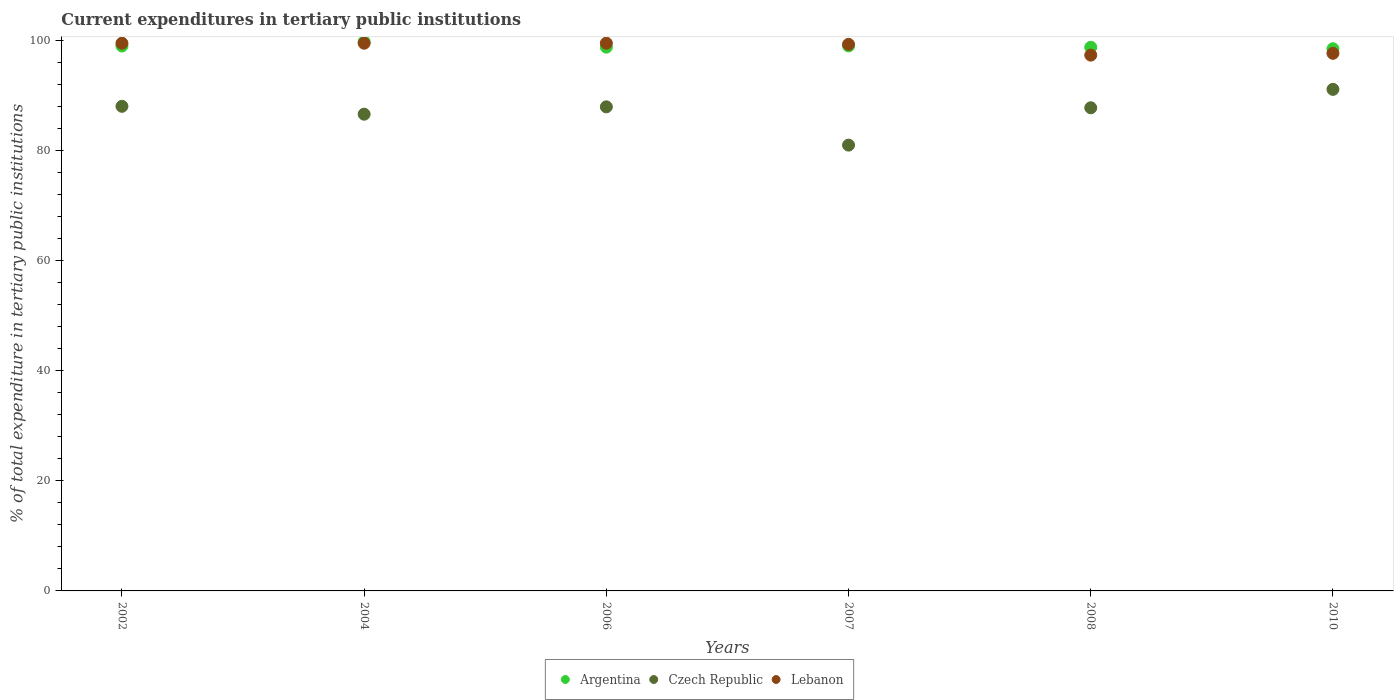How many different coloured dotlines are there?
Keep it short and to the point. 3. Is the number of dotlines equal to the number of legend labels?
Your answer should be compact. Yes. What is the current expenditures in tertiary public institutions in Czech Republic in 2002?
Your answer should be very brief. 88.1. Across all years, what is the maximum current expenditures in tertiary public institutions in Czech Republic?
Keep it short and to the point. 91.18. Across all years, what is the minimum current expenditures in tertiary public institutions in Lebanon?
Ensure brevity in your answer.  97.41. In which year was the current expenditures in tertiary public institutions in Argentina maximum?
Keep it short and to the point. 2004. In which year was the current expenditures in tertiary public institutions in Czech Republic minimum?
Give a very brief answer. 2007. What is the total current expenditures in tertiary public institutions in Czech Republic in the graph?
Your answer should be compact. 522.85. What is the difference between the current expenditures in tertiary public institutions in Argentina in 2007 and that in 2010?
Keep it short and to the point. 0.52. What is the difference between the current expenditures in tertiary public institutions in Lebanon in 2004 and the current expenditures in tertiary public institutions in Czech Republic in 2008?
Your answer should be very brief. 11.74. What is the average current expenditures in tertiary public institutions in Czech Republic per year?
Provide a short and direct response. 87.14. In the year 2006, what is the difference between the current expenditures in tertiary public institutions in Lebanon and current expenditures in tertiary public institutions in Argentina?
Provide a succinct answer. 0.71. In how many years, is the current expenditures in tertiary public institutions in Argentina greater than 36 %?
Provide a succinct answer. 6. What is the ratio of the current expenditures in tertiary public institutions in Czech Republic in 2002 to that in 2007?
Give a very brief answer. 1.09. What is the difference between the highest and the second highest current expenditures in tertiary public institutions in Lebanon?
Provide a succinct answer. 0. What is the difference between the highest and the lowest current expenditures in tertiary public institutions in Lebanon?
Provide a short and direct response. 2.17. Is the sum of the current expenditures in tertiary public institutions in Argentina in 2002 and 2006 greater than the maximum current expenditures in tertiary public institutions in Czech Republic across all years?
Keep it short and to the point. Yes. Does the current expenditures in tertiary public institutions in Argentina monotonically increase over the years?
Provide a succinct answer. No. How many dotlines are there?
Provide a succinct answer. 3. What is the difference between two consecutive major ticks on the Y-axis?
Keep it short and to the point. 20. Are the values on the major ticks of Y-axis written in scientific E-notation?
Your answer should be compact. No. Does the graph contain any zero values?
Your answer should be very brief. No. Where does the legend appear in the graph?
Your answer should be compact. Bottom center. What is the title of the graph?
Offer a very short reply. Current expenditures in tertiary public institutions. What is the label or title of the X-axis?
Provide a succinct answer. Years. What is the label or title of the Y-axis?
Give a very brief answer. % of total expenditure in tertiary public institutions. What is the % of total expenditure in tertiary public institutions of Argentina in 2002?
Your response must be concise. 99.07. What is the % of total expenditure in tertiary public institutions of Czech Republic in 2002?
Provide a short and direct response. 88.1. What is the % of total expenditure in tertiary public institutions of Lebanon in 2002?
Your response must be concise. 99.57. What is the % of total expenditure in tertiary public institutions of Argentina in 2004?
Your answer should be very brief. 99.84. What is the % of total expenditure in tertiary public institutions of Czech Republic in 2004?
Give a very brief answer. 86.67. What is the % of total expenditure in tertiary public institutions of Lebanon in 2004?
Your answer should be compact. 99.57. What is the % of total expenditure in tertiary public institutions in Argentina in 2006?
Give a very brief answer. 98.86. What is the % of total expenditure in tertiary public institutions of Czech Republic in 2006?
Your response must be concise. 88.01. What is the % of total expenditure in tertiary public institutions of Lebanon in 2006?
Your answer should be very brief. 99.58. What is the % of total expenditure in tertiary public institutions of Argentina in 2007?
Give a very brief answer. 99.08. What is the % of total expenditure in tertiary public institutions of Czech Republic in 2007?
Your answer should be very brief. 81.05. What is the % of total expenditure in tertiary public institutions in Lebanon in 2007?
Provide a short and direct response. 99.38. What is the % of total expenditure in tertiary public institutions in Argentina in 2008?
Your answer should be compact. 98.84. What is the % of total expenditure in tertiary public institutions in Czech Republic in 2008?
Provide a short and direct response. 87.84. What is the % of total expenditure in tertiary public institutions of Lebanon in 2008?
Your answer should be very brief. 97.41. What is the % of total expenditure in tertiary public institutions in Argentina in 2010?
Keep it short and to the point. 98.56. What is the % of total expenditure in tertiary public institutions in Czech Republic in 2010?
Your answer should be compact. 91.18. What is the % of total expenditure in tertiary public institutions of Lebanon in 2010?
Offer a terse response. 97.74. Across all years, what is the maximum % of total expenditure in tertiary public institutions in Argentina?
Provide a succinct answer. 99.84. Across all years, what is the maximum % of total expenditure in tertiary public institutions in Czech Republic?
Your answer should be compact. 91.18. Across all years, what is the maximum % of total expenditure in tertiary public institutions in Lebanon?
Offer a very short reply. 99.58. Across all years, what is the minimum % of total expenditure in tertiary public institutions of Argentina?
Give a very brief answer. 98.56. Across all years, what is the minimum % of total expenditure in tertiary public institutions in Czech Republic?
Ensure brevity in your answer.  81.05. Across all years, what is the minimum % of total expenditure in tertiary public institutions of Lebanon?
Provide a succinct answer. 97.41. What is the total % of total expenditure in tertiary public institutions in Argentina in the graph?
Offer a terse response. 594.25. What is the total % of total expenditure in tertiary public institutions of Czech Republic in the graph?
Offer a terse response. 522.85. What is the total % of total expenditure in tertiary public institutions of Lebanon in the graph?
Your answer should be compact. 593.24. What is the difference between the % of total expenditure in tertiary public institutions of Argentina in 2002 and that in 2004?
Your answer should be compact. -0.77. What is the difference between the % of total expenditure in tertiary public institutions in Czech Republic in 2002 and that in 2004?
Offer a terse response. 1.43. What is the difference between the % of total expenditure in tertiary public institutions of Lebanon in 2002 and that in 2004?
Give a very brief answer. -0. What is the difference between the % of total expenditure in tertiary public institutions in Argentina in 2002 and that in 2006?
Keep it short and to the point. 0.2. What is the difference between the % of total expenditure in tertiary public institutions in Czech Republic in 2002 and that in 2006?
Ensure brevity in your answer.  0.09. What is the difference between the % of total expenditure in tertiary public institutions of Lebanon in 2002 and that in 2006?
Give a very brief answer. -0. What is the difference between the % of total expenditure in tertiary public institutions in Argentina in 2002 and that in 2007?
Ensure brevity in your answer.  -0.02. What is the difference between the % of total expenditure in tertiary public institutions of Czech Republic in 2002 and that in 2007?
Provide a succinct answer. 7.05. What is the difference between the % of total expenditure in tertiary public institutions in Lebanon in 2002 and that in 2007?
Your answer should be very brief. 0.2. What is the difference between the % of total expenditure in tertiary public institutions of Argentina in 2002 and that in 2008?
Keep it short and to the point. 0.23. What is the difference between the % of total expenditure in tertiary public institutions in Czech Republic in 2002 and that in 2008?
Make the answer very short. 0.26. What is the difference between the % of total expenditure in tertiary public institutions in Lebanon in 2002 and that in 2008?
Give a very brief answer. 2.16. What is the difference between the % of total expenditure in tertiary public institutions in Argentina in 2002 and that in 2010?
Your answer should be very brief. 0.5. What is the difference between the % of total expenditure in tertiary public institutions in Czech Republic in 2002 and that in 2010?
Your answer should be compact. -3.08. What is the difference between the % of total expenditure in tertiary public institutions in Lebanon in 2002 and that in 2010?
Your answer should be compact. 1.84. What is the difference between the % of total expenditure in tertiary public institutions of Argentina in 2004 and that in 2006?
Ensure brevity in your answer.  0.98. What is the difference between the % of total expenditure in tertiary public institutions of Czech Republic in 2004 and that in 2006?
Your answer should be very brief. -1.34. What is the difference between the % of total expenditure in tertiary public institutions of Lebanon in 2004 and that in 2006?
Provide a succinct answer. -0. What is the difference between the % of total expenditure in tertiary public institutions in Argentina in 2004 and that in 2007?
Offer a very short reply. 0.76. What is the difference between the % of total expenditure in tertiary public institutions of Czech Republic in 2004 and that in 2007?
Your answer should be compact. 5.62. What is the difference between the % of total expenditure in tertiary public institutions of Lebanon in 2004 and that in 2007?
Make the answer very short. 0.2. What is the difference between the % of total expenditure in tertiary public institutions in Argentina in 2004 and that in 2008?
Provide a succinct answer. 1. What is the difference between the % of total expenditure in tertiary public institutions of Czech Republic in 2004 and that in 2008?
Make the answer very short. -1.17. What is the difference between the % of total expenditure in tertiary public institutions of Lebanon in 2004 and that in 2008?
Keep it short and to the point. 2.17. What is the difference between the % of total expenditure in tertiary public institutions of Argentina in 2004 and that in 2010?
Provide a succinct answer. 1.28. What is the difference between the % of total expenditure in tertiary public institutions in Czech Republic in 2004 and that in 2010?
Make the answer very short. -4.51. What is the difference between the % of total expenditure in tertiary public institutions in Lebanon in 2004 and that in 2010?
Keep it short and to the point. 1.84. What is the difference between the % of total expenditure in tertiary public institutions in Argentina in 2006 and that in 2007?
Offer a terse response. -0.22. What is the difference between the % of total expenditure in tertiary public institutions in Czech Republic in 2006 and that in 2007?
Give a very brief answer. 6.96. What is the difference between the % of total expenditure in tertiary public institutions in Lebanon in 2006 and that in 2007?
Offer a very short reply. 0.2. What is the difference between the % of total expenditure in tertiary public institutions of Argentina in 2006 and that in 2008?
Provide a short and direct response. 0.02. What is the difference between the % of total expenditure in tertiary public institutions of Czech Republic in 2006 and that in 2008?
Your response must be concise. 0.17. What is the difference between the % of total expenditure in tertiary public institutions in Lebanon in 2006 and that in 2008?
Give a very brief answer. 2.17. What is the difference between the % of total expenditure in tertiary public institutions in Argentina in 2006 and that in 2010?
Ensure brevity in your answer.  0.3. What is the difference between the % of total expenditure in tertiary public institutions in Czech Republic in 2006 and that in 2010?
Provide a succinct answer. -3.18. What is the difference between the % of total expenditure in tertiary public institutions of Lebanon in 2006 and that in 2010?
Offer a very short reply. 1.84. What is the difference between the % of total expenditure in tertiary public institutions of Argentina in 2007 and that in 2008?
Give a very brief answer. 0.25. What is the difference between the % of total expenditure in tertiary public institutions in Czech Republic in 2007 and that in 2008?
Ensure brevity in your answer.  -6.79. What is the difference between the % of total expenditure in tertiary public institutions in Lebanon in 2007 and that in 2008?
Keep it short and to the point. 1.97. What is the difference between the % of total expenditure in tertiary public institutions of Argentina in 2007 and that in 2010?
Your answer should be compact. 0.52. What is the difference between the % of total expenditure in tertiary public institutions in Czech Republic in 2007 and that in 2010?
Offer a very short reply. -10.14. What is the difference between the % of total expenditure in tertiary public institutions in Lebanon in 2007 and that in 2010?
Provide a short and direct response. 1.64. What is the difference between the % of total expenditure in tertiary public institutions in Argentina in 2008 and that in 2010?
Your answer should be very brief. 0.27. What is the difference between the % of total expenditure in tertiary public institutions of Czech Republic in 2008 and that in 2010?
Provide a succinct answer. -3.35. What is the difference between the % of total expenditure in tertiary public institutions of Lebanon in 2008 and that in 2010?
Your response must be concise. -0.33. What is the difference between the % of total expenditure in tertiary public institutions in Argentina in 2002 and the % of total expenditure in tertiary public institutions in Czech Republic in 2004?
Keep it short and to the point. 12.4. What is the difference between the % of total expenditure in tertiary public institutions of Argentina in 2002 and the % of total expenditure in tertiary public institutions of Lebanon in 2004?
Provide a short and direct response. -0.51. What is the difference between the % of total expenditure in tertiary public institutions in Czech Republic in 2002 and the % of total expenditure in tertiary public institutions in Lebanon in 2004?
Keep it short and to the point. -11.47. What is the difference between the % of total expenditure in tertiary public institutions in Argentina in 2002 and the % of total expenditure in tertiary public institutions in Czech Republic in 2006?
Your answer should be compact. 11.06. What is the difference between the % of total expenditure in tertiary public institutions in Argentina in 2002 and the % of total expenditure in tertiary public institutions in Lebanon in 2006?
Offer a very short reply. -0.51. What is the difference between the % of total expenditure in tertiary public institutions of Czech Republic in 2002 and the % of total expenditure in tertiary public institutions of Lebanon in 2006?
Give a very brief answer. -11.47. What is the difference between the % of total expenditure in tertiary public institutions of Argentina in 2002 and the % of total expenditure in tertiary public institutions of Czech Republic in 2007?
Provide a short and direct response. 18.02. What is the difference between the % of total expenditure in tertiary public institutions in Argentina in 2002 and the % of total expenditure in tertiary public institutions in Lebanon in 2007?
Your answer should be very brief. -0.31. What is the difference between the % of total expenditure in tertiary public institutions of Czech Republic in 2002 and the % of total expenditure in tertiary public institutions of Lebanon in 2007?
Offer a terse response. -11.27. What is the difference between the % of total expenditure in tertiary public institutions of Argentina in 2002 and the % of total expenditure in tertiary public institutions of Czech Republic in 2008?
Offer a terse response. 11.23. What is the difference between the % of total expenditure in tertiary public institutions in Argentina in 2002 and the % of total expenditure in tertiary public institutions in Lebanon in 2008?
Ensure brevity in your answer.  1.66. What is the difference between the % of total expenditure in tertiary public institutions of Czech Republic in 2002 and the % of total expenditure in tertiary public institutions of Lebanon in 2008?
Your answer should be very brief. -9.31. What is the difference between the % of total expenditure in tertiary public institutions of Argentina in 2002 and the % of total expenditure in tertiary public institutions of Czech Republic in 2010?
Your answer should be very brief. 7.88. What is the difference between the % of total expenditure in tertiary public institutions of Argentina in 2002 and the % of total expenditure in tertiary public institutions of Lebanon in 2010?
Offer a very short reply. 1.33. What is the difference between the % of total expenditure in tertiary public institutions of Czech Republic in 2002 and the % of total expenditure in tertiary public institutions of Lebanon in 2010?
Provide a short and direct response. -9.63. What is the difference between the % of total expenditure in tertiary public institutions in Argentina in 2004 and the % of total expenditure in tertiary public institutions in Czech Republic in 2006?
Keep it short and to the point. 11.83. What is the difference between the % of total expenditure in tertiary public institutions of Argentina in 2004 and the % of total expenditure in tertiary public institutions of Lebanon in 2006?
Keep it short and to the point. 0.27. What is the difference between the % of total expenditure in tertiary public institutions of Czech Republic in 2004 and the % of total expenditure in tertiary public institutions of Lebanon in 2006?
Give a very brief answer. -12.91. What is the difference between the % of total expenditure in tertiary public institutions in Argentina in 2004 and the % of total expenditure in tertiary public institutions in Czech Republic in 2007?
Offer a very short reply. 18.79. What is the difference between the % of total expenditure in tertiary public institutions in Argentina in 2004 and the % of total expenditure in tertiary public institutions in Lebanon in 2007?
Offer a very short reply. 0.47. What is the difference between the % of total expenditure in tertiary public institutions of Czech Republic in 2004 and the % of total expenditure in tertiary public institutions of Lebanon in 2007?
Your answer should be very brief. -12.71. What is the difference between the % of total expenditure in tertiary public institutions in Argentina in 2004 and the % of total expenditure in tertiary public institutions in Czech Republic in 2008?
Make the answer very short. 12. What is the difference between the % of total expenditure in tertiary public institutions in Argentina in 2004 and the % of total expenditure in tertiary public institutions in Lebanon in 2008?
Offer a terse response. 2.43. What is the difference between the % of total expenditure in tertiary public institutions of Czech Republic in 2004 and the % of total expenditure in tertiary public institutions of Lebanon in 2008?
Your answer should be very brief. -10.74. What is the difference between the % of total expenditure in tertiary public institutions of Argentina in 2004 and the % of total expenditure in tertiary public institutions of Czech Republic in 2010?
Your response must be concise. 8.66. What is the difference between the % of total expenditure in tertiary public institutions in Argentina in 2004 and the % of total expenditure in tertiary public institutions in Lebanon in 2010?
Your response must be concise. 2.11. What is the difference between the % of total expenditure in tertiary public institutions in Czech Republic in 2004 and the % of total expenditure in tertiary public institutions in Lebanon in 2010?
Ensure brevity in your answer.  -11.07. What is the difference between the % of total expenditure in tertiary public institutions of Argentina in 2006 and the % of total expenditure in tertiary public institutions of Czech Republic in 2007?
Ensure brevity in your answer.  17.81. What is the difference between the % of total expenditure in tertiary public institutions in Argentina in 2006 and the % of total expenditure in tertiary public institutions in Lebanon in 2007?
Your answer should be compact. -0.51. What is the difference between the % of total expenditure in tertiary public institutions in Czech Republic in 2006 and the % of total expenditure in tertiary public institutions in Lebanon in 2007?
Give a very brief answer. -11.37. What is the difference between the % of total expenditure in tertiary public institutions of Argentina in 2006 and the % of total expenditure in tertiary public institutions of Czech Republic in 2008?
Provide a succinct answer. 11.02. What is the difference between the % of total expenditure in tertiary public institutions of Argentina in 2006 and the % of total expenditure in tertiary public institutions of Lebanon in 2008?
Offer a very short reply. 1.45. What is the difference between the % of total expenditure in tertiary public institutions of Czech Republic in 2006 and the % of total expenditure in tertiary public institutions of Lebanon in 2008?
Ensure brevity in your answer.  -9.4. What is the difference between the % of total expenditure in tertiary public institutions of Argentina in 2006 and the % of total expenditure in tertiary public institutions of Czech Republic in 2010?
Offer a terse response. 7.68. What is the difference between the % of total expenditure in tertiary public institutions in Argentina in 2006 and the % of total expenditure in tertiary public institutions in Lebanon in 2010?
Make the answer very short. 1.13. What is the difference between the % of total expenditure in tertiary public institutions of Czech Republic in 2006 and the % of total expenditure in tertiary public institutions of Lebanon in 2010?
Provide a succinct answer. -9.73. What is the difference between the % of total expenditure in tertiary public institutions in Argentina in 2007 and the % of total expenditure in tertiary public institutions in Czech Republic in 2008?
Ensure brevity in your answer.  11.25. What is the difference between the % of total expenditure in tertiary public institutions of Argentina in 2007 and the % of total expenditure in tertiary public institutions of Lebanon in 2008?
Offer a very short reply. 1.68. What is the difference between the % of total expenditure in tertiary public institutions of Czech Republic in 2007 and the % of total expenditure in tertiary public institutions of Lebanon in 2008?
Offer a very short reply. -16.36. What is the difference between the % of total expenditure in tertiary public institutions of Argentina in 2007 and the % of total expenditure in tertiary public institutions of Czech Republic in 2010?
Offer a very short reply. 7.9. What is the difference between the % of total expenditure in tertiary public institutions of Argentina in 2007 and the % of total expenditure in tertiary public institutions of Lebanon in 2010?
Keep it short and to the point. 1.35. What is the difference between the % of total expenditure in tertiary public institutions in Czech Republic in 2007 and the % of total expenditure in tertiary public institutions in Lebanon in 2010?
Provide a succinct answer. -16.69. What is the difference between the % of total expenditure in tertiary public institutions in Argentina in 2008 and the % of total expenditure in tertiary public institutions in Czech Republic in 2010?
Provide a succinct answer. 7.65. What is the difference between the % of total expenditure in tertiary public institutions of Argentina in 2008 and the % of total expenditure in tertiary public institutions of Lebanon in 2010?
Offer a terse response. 1.1. What is the difference between the % of total expenditure in tertiary public institutions in Czech Republic in 2008 and the % of total expenditure in tertiary public institutions in Lebanon in 2010?
Ensure brevity in your answer.  -9.9. What is the average % of total expenditure in tertiary public institutions in Argentina per year?
Provide a succinct answer. 99.04. What is the average % of total expenditure in tertiary public institutions in Czech Republic per year?
Ensure brevity in your answer.  87.14. What is the average % of total expenditure in tertiary public institutions of Lebanon per year?
Provide a succinct answer. 98.87. In the year 2002, what is the difference between the % of total expenditure in tertiary public institutions in Argentina and % of total expenditure in tertiary public institutions in Czech Republic?
Ensure brevity in your answer.  10.96. In the year 2002, what is the difference between the % of total expenditure in tertiary public institutions of Argentina and % of total expenditure in tertiary public institutions of Lebanon?
Your answer should be compact. -0.51. In the year 2002, what is the difference between the % of total expenditure in tertiary public institutions of Czech Republic and % of total expenditure in tertiary public institutions of Lebanon?
Offer a very short reply. -11.47. In the year 2004, what is the difference between the % of total expenditure in tertiary public institutions in Argentina and % of total expenditure in tertiary public institutions in Czech Republic?
Provide a short and direct response. 13.17. In the year 2004, what is the difference between the % of total expenditure in tertiary public institutions in Argentina and % of total expenditure in tertiary public institutions in Lebanon?
Keep it short and to the point. 0.27. In the year 2004, what is the difference between the % of total expenditure in tertiary public institutions of Czech Republic and % of total expenditure in tertiary public institutions of Lebanon?
Make the answer very short. -12.9. In the year 2006, what is the difference between the % of total expenditure in tertiary public institutions in Argentina and % of total expenditure in tertiary public institutions in Czech Republic?
Your answer should be very brief. 10.85. In the year 2006, what is the difference between the % of total expenditure in tertiary public institutions in Argentina and % of total expenditure in tertiary public institutions in Lebanon?
Give a very brief answer. -0.71. In the year 2006, what is the difference between the % of total expenditure in tertiary public institutions in Czech Republic and % of total expenditure in tertiary public institutions in Lebanon?
Offer a terse response. -11.57. In the year 2007, what is the difference between the % of total expenditure in tertiary public institutions in Argentina and % of total expenditure in tertiary public institutions in Czech Republic?
Your answer should be very brief. 18.04. In the year 2007, what is the difference between the % of total expenditure in tertiary public institutions in Argentina and % of total expenditure in tertiary public institutions in Lebanon?
Your answer should be compact. -0.29. In the year 2007, what is the difference between the % of total expenditure in tertiary public institutions in Czech Republic and % of total expenditure in tertiary public institutions in Lebanon?
Provide a succinct answer. -18.33. In the year 2008, what is the difference between the % of total expenditure in tertiary public institutions in Argentina and % of total expenditure in tertiary public institutions in Czech Republic?
Provide a succinct answer. 11. In the year 2008, what is the difference between the % of total expenditure in tertiary public institutions of Argentina and % of total expenditure in tertiary public institutions of Lebanon?
Make the answer very short. 1.43. In the year 2008, what is the difference between the % of total expenditure in tertiary public institutions in Czech Republic and % of total expenditure in tertiary public institutions in Lebanon?
Offer a terse response. -9.57. In the year 2010, what is the difference between the % of total expenditure in tertiary public institutions in Argentina and % of total expenditure in tertiary public institutions in Czech Republic?
Keep it short and to the point. 7.38. In the year 2010, what is the difference between the % of total expenditure in tertiary public institutions of Argentina and % of total expenditure in tertiary public institutions of Lebanon?
Give a very brief answer. 0.83. In the year 2010, what is the difference between the % of total expenditure in tertiary public institutions in Czech Republic and % of total expenditure in tertiary public institutions in Lebanon?
Offer a very short reply. -6.55. What is the ratio of the % of total expenditure in tertiary public institutions of Argentina in 2002 to that in 2004?
Provide a short and direct response. 0.99. What is the ratio of the % of total expenditure in tertiary public institutions of Czech Republic in 2002 to that in 2004?
Keep it short and to the point. 1.02. What is the ratio of the % of total expenditure in tertiary public institutions of Czech Republic in 2002 to that in 2006?
Your answer should be very brief. 1. What is the ratio of the % of total expenditure in tertiary public institutions in Lebanon in 2002 to that in 2006?
Keep it short and to the point. 1. What is the ratio of the % of total expenditure in tertiary public institutions in Argentina in 2002 to that in 2007?
Provide a succinct answer. 1. What is the ratio of the % of total expenditure in tertiary public institutions in Czech Republic in 2002 to that in 2007?
Provide a short and direct response. 1.09. What is the ratio of the % of total expenditure in tertiary public institutions in Lebanon in 2002 to that in 2008?
Provide a short and direct response. 1.02. What is the ratio of the % of total expenditure in tertiary public institutions of Czech Republic in 2002 to that in 2010?
Ensure brevity in your answer.  0.97. What is the ratio of the % of total expenditure in tertiary public institutions in Lebanon in 2002 to that in 2010?
Give a very brief answer. 1.02. What is the ratio of the % of total expenditure in tertiary public institutions of Argentina in 2004 to that in 2006?
Your response must be concise. 1.01. What is the ratio of the % of total expenditure in tertiary public institutions of Lebanon in 2004 to that in 2006?
Make the answer very short. 1. What is the ratio of the % of total expenditure in tertiary public institutions of Argentina in 2004 to that in 2007?
Make the answer very short. 1.01. What is the ratio of the % of total expenditure in tertiary public institutions in Czech Republic in 2004 to that in 2007?
Offer a very short reply. 1.07. What is the ratio of the % of total expenditure in tertiary public institutions in Argentina in 2004 to that in 2008?
Give a very brief answer. 1.01. What is the ratio of the % of total expenditure in tertiary public institutions of Czech Republic in 2004 to that in 2008?
Ensure brevity in your answer.  0.99. What is the ratio of the % of total expenditure in tertiary public institutions of Lebanon in 2004 to that in 2008?
Make the answer very short. 1.02. What is the ratio of the % of total expenditure in tertiary public institutions in Argentina in 2004 to that in 2010?
Your answer should be very brief. 1.01. What is the ratio of the % of total expenditure in tertiary public institutions of Czech Republic in 2004 to that in 2010?
Provide a succinct answer. 0.95. What is the ratio of the % of total expenditure in tertiary public institutions of Lebanon in 2004 to that in 2010?
Provide a short and direct response. 1.02. What is the ratio of the % of total expenditure in tertiary public institutions in Czech Republic in 2006 to that in 2007?
Your answer should be very brief. 1.09. What is the ratio of the % of total expenditure in tertiary public institutions in Czech Republic in 2006 to that in 2008?
Provide a succinct answer. 1. What is the ratio of the % of total expenditure in tertiary public institutions of Lebanon in 2006 to that in 2008?
Offer a terse response. 1.02. What is the ratio of the % of total expenditure in tertiary public institutions in Argentina in 2006 to that in 2010?
Give a very brief answer. 1. What is the ratio of the % of total expenditure in tertiary public institutions in Czech Republic in 2006 to that in 2010?
Provide a succinct answer. 0.97. What is the ratio of the % of total expenditure in tertiary public institutions in Lebanon in 2006 to that in 2010?
Ensure brevity in your answer.  1.02. What is the ratio of the % of total expenditure in tertiary public institutions in Czech Republic in 2007 to that in 2008?
Offer a terse response. 0.92. What is the ratio of the % of total expenditure in tertiary public institutions in Lebanon in 2007 to that in 2008?
Provide a short and direct response. 1.02. What is the ratio of the % of total expenditure in tertiary public institutions in Czech Republic in 2007 to that in 2010?
Your answer should be compact. 0.89. What is the ratio of the % of total expenditure in tertiary public institutions in Lebanon in 2007 to that in 2010?
Give a very brief answer. 1.02. What is the ratio of the % of total expenditure in tertiary public institutions in Czech Republic in 2008 to that in 2010?
Your answer should be very brief. 0.96. What is the difference between the highest and the second highest % of total expenditure in tertiary public institutions in Argentina?
Your answer should be very brief. 0.76. What is the difference between the highest and the second highest % of total expenditure in tertiary public institutions of Czech Republic?
Provide a succinct answer. 3.08. What is the difference between the highest and the second highest % of total expenditure in tertiary public institutions of Lebanon?
Your answer should be very brief. 0. What is the difference between the highest and the lowest % of total expenditure in tertiary public institutions in Argentina?
Make the answer very short. 1.28. What is the difference between the highest and the lowest % of total expenditure in tertiary public institutions of Czech Republic?
Offer a terse response. 10.14. What is the difference between the highest and the lowest % of total expenditure in tertiary public institutions of Lebanon?
Your response must be concise. 2.17. 